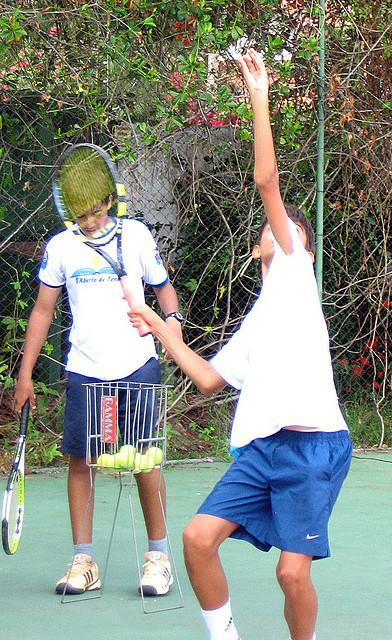What color are the interior nettings of the rackets used by the two men? Please explain your reasoning. green. Men are playing tennis with rackets with green strings. 